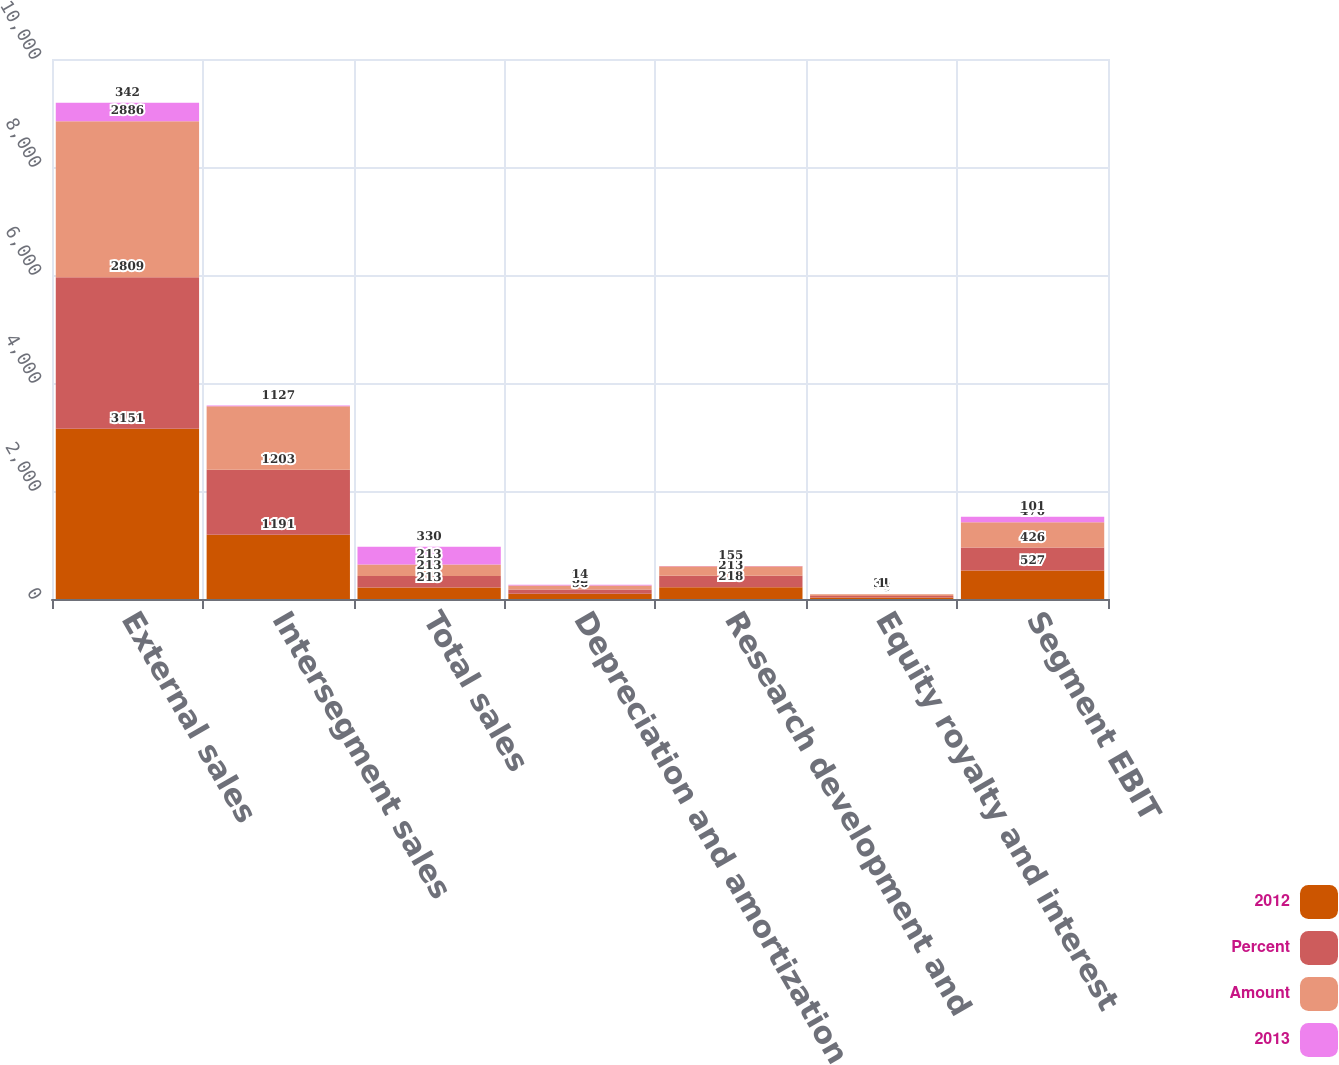<chart> <loc_0><loc_0><loc_500><loc_500><stacked_bar_chart><ecel><fcel>External sales<fcel>Intersegment sales<fcel>Total sales<fcel>Depreciation and amortization<fcel>Research development and<fcel>Equity royalty and interest<fcel>Segment EBIT<nl><fcel>2012<fcel>3151<fcel>1191<fcel>213<fcel>96<fcel>218<fcel>28<fcel>527<nl><fcel>Percent<fcel>2809<fcel>1203<fcel>213<fcel>82<fcel>213<fcel>29<fcel>426<nl><fcel>Amount<fcel>2886<fcel>1177<fcel>213<fcel>73<fcel>175<fcel>31<fcel>470<nl><fcel>2013<fcel>342<fcel>12<fcel>330<fcel>14<fcel>5<fcel>1<fcel>101<nl></chart> 